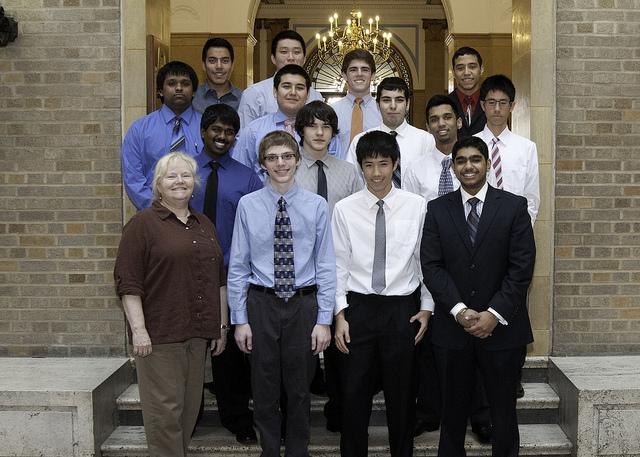Is this a zoo?
Give a very brief answer. No. How many people are wearing ties?
Be succinct. 13. Does the shirt have sleeves?
Be succinct. Yes. How many men are there?
Short answer required. 14. Is one of the guys holding a drink in his hand?
Answer briefly. No. How many people are wearing jackets?
Give a very brief answer. 2. Can you deduce anything about this man's hairstyle?
Give a very brief answer. No. How many women are in this photo?
Short answer required. 1. Is this photo black and white?
Give a very brief answer. No. Do they have matching clothes?
Short answer required. No. What religion does this man represent?
Give a very brief answer. Catholic. What are the kids wearing?
Short answer required. Suits. How many people are in this scene?
Give a very brief answer. 15. How many people are in this picture?
Answer briefly. 15. Is there a clock in this photo?
Answer briefly. No. Is this a vintage picture?
Quick response, please. No. Is the man holding a meat skewer in his hands?
Be succinct. No. Would these people have coffee together?
Answer briefly. Yes. Who is having their picture taken?
Be succinct. Students. What is the number of lights on each chandelier?
Quick response, please. 14. 